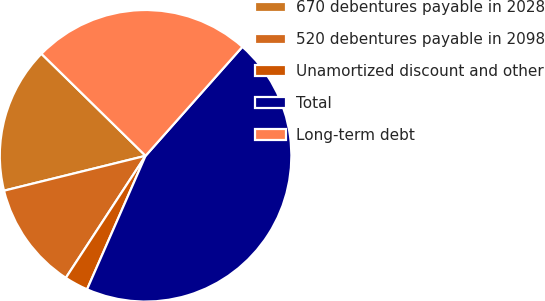<chart> <loc_0><loc_0><loc_500><loc_500><pie_chart><fcel>670 debentures payable in 2028<fcel>520 debentures payable in 2098<fcel>Unamortized discount and other<fcel>Total<fcel>Long-term debt<nl><fcel>16.18%<fcel>11.94%<fcel>2.64%<fcel>45.01%<fcel>24.22%<nl></chart> 